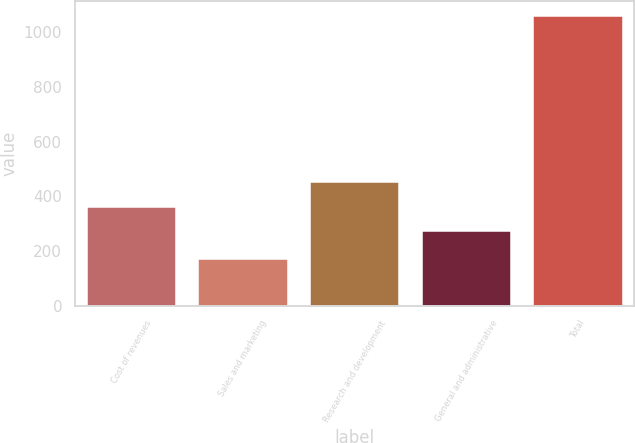<chart> <loc_0><loc_0><loc_500><loc_500><bar_chart><fcel>Cost of revenues<fcel>Sales and marketing<fcel>Research and development<fcel>General and administrative<fcel>Total<nl><fcel>362<fcel>171<fcel>451<fcel>273<fcel>1061<nl></chart> 